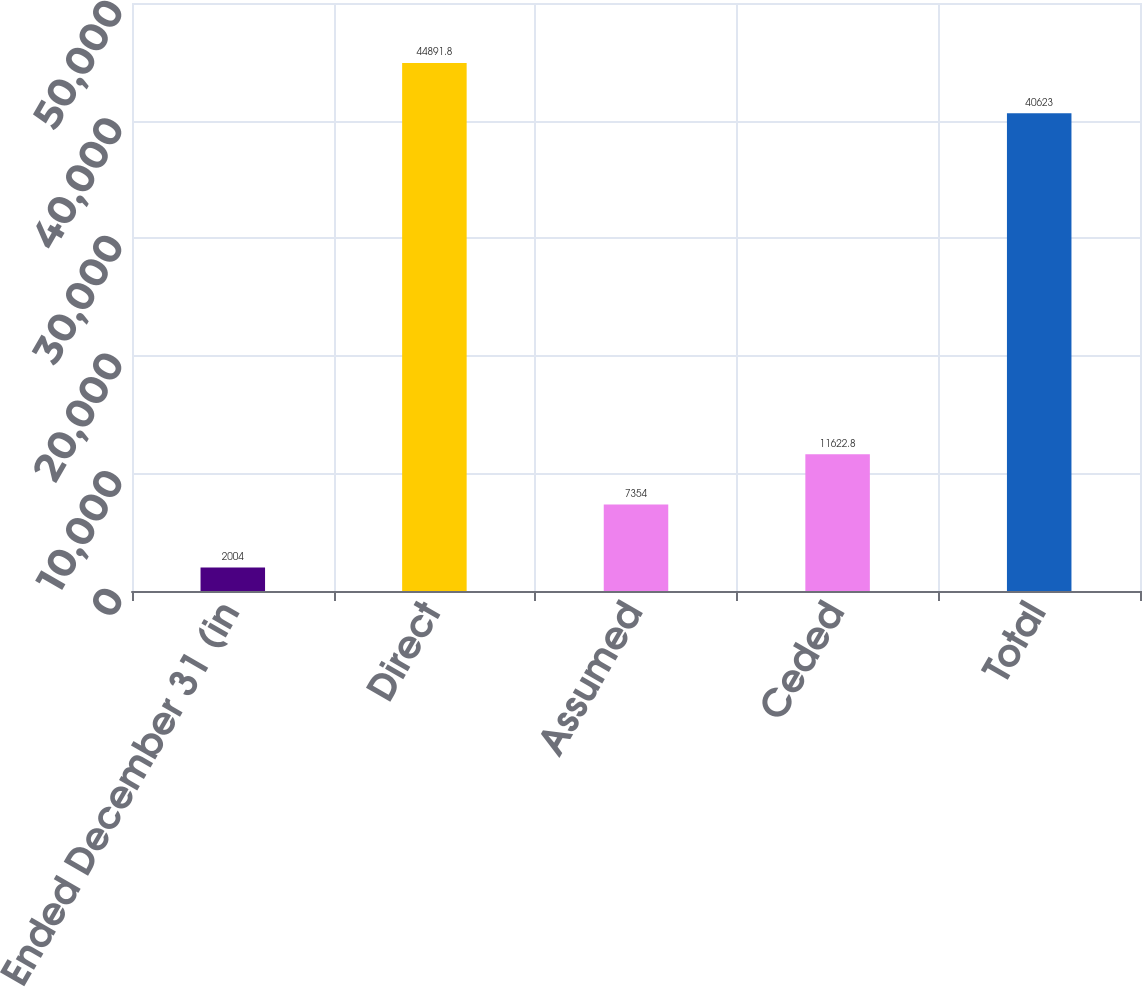Convert chart to OTSL. <chart><loc_0><loc_0><loc_500><loc_500><bar_chart><fcel>Years Ended December 31 (in<fcel>Direct<fcel>Assumed<fcel>Ceded<fcel>Total<nl><fcel>2004<fcel>44891.8<fcel>7354<fcel>11622.8<fcel>40623<nl></chart> 